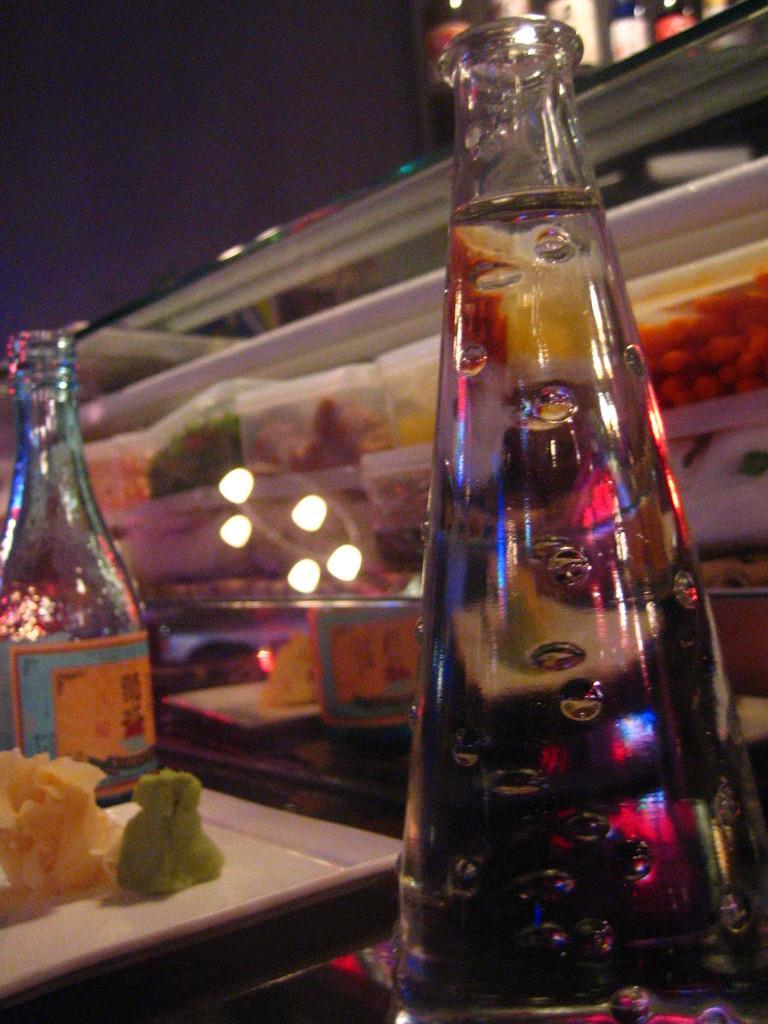Please provide a concise description of this image. This picture is consists of a glass bottle which is placed on the table at the right side of the image, there is a tray which contains food item, and there is another glass bottle at the left side of the image, there is a glass food container at the center of the image. 